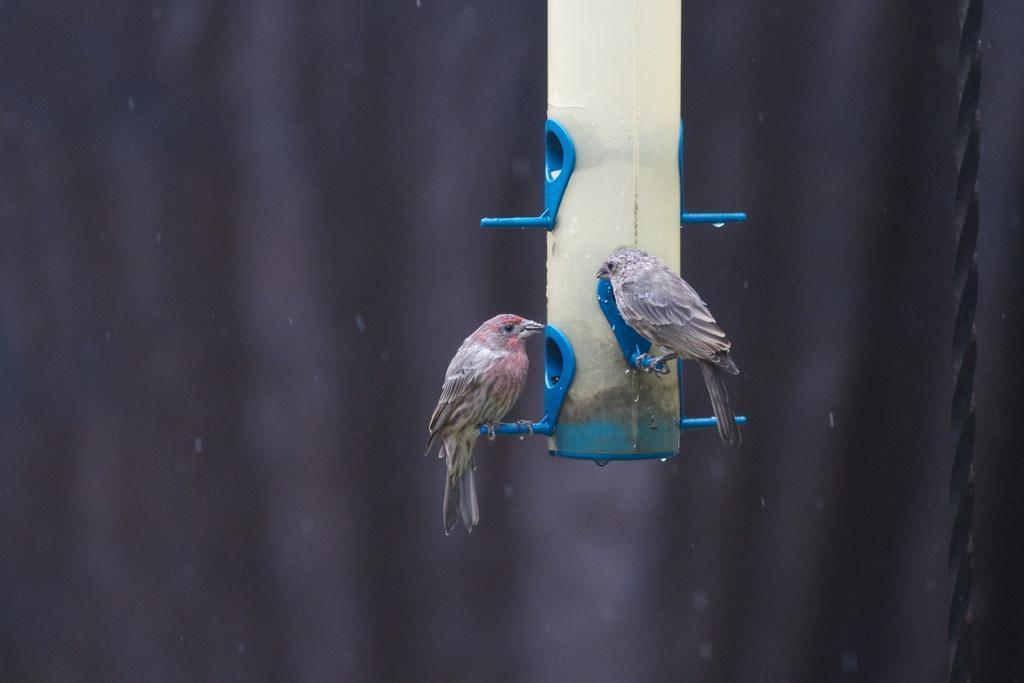Please provide a concise description of this image. These are the two beautiful birds that are standing on blue color things. 